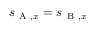Convert formula to latex. <formula><loc_0><loc_0><loc_500><loc_500>s _ { A , x } = s _ { B , x }</formula> 